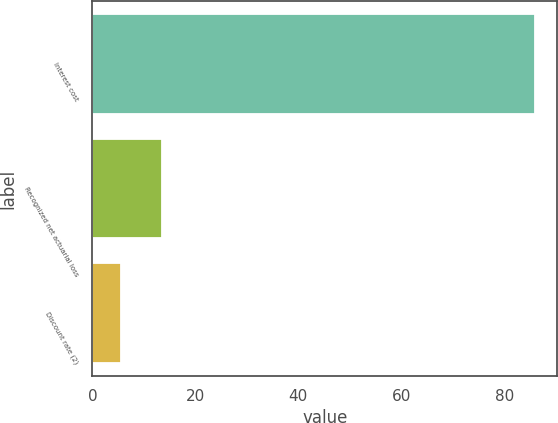Convert chart to OTSL. <chart><loc_0><loc_0><loc_500><loc_500><bar_chart><fcel>Interest cost<fcel>Recognized net actuarial loss<fcel>Discount rate (2)<nl><fcel>86<fcel>13.55<fcel>5.5<nl></chart> 